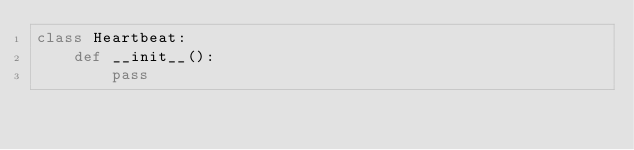Convert code to text. <code><loc_0><loc_0><loc_500><loc_500><_Python_>class Heartbeat:
    def __init__():
        pass</code> 